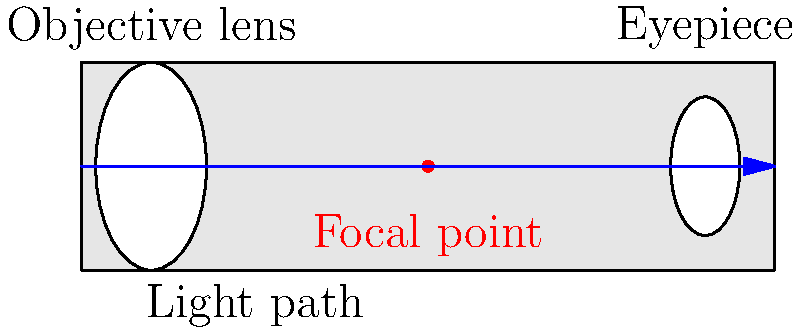In this cross-sectional diagram of a telescope, which component is responsible for gathering and focusing light from distant celestial objects, much like how a cinematographer captures expansive landscapes in classic Kannada films? To answer this question, let's break down the components of a telescope and their functions:

1. The telescope consists of two main optical components: the objective lens and the eyepiece.

2. The objective lens is the larger lens located at the front of the telescope (left side in the diagram). Its primary functions are:
   a) Gathering light from distant objects
   b) Focusing that light to form an image

3. The eyepiece is the smaller lens located at the back of the telescope (right side in the diagram). Its main function is to magnify the image formed by the objective lens.

4. The focal point, shown as a red dot in the diagram, is where the light rays converge after passing through the objective lens.

5. In cinematography, the camera lens serves a similar purpose to the objective lens in a telescope. It gathers light and focuses it to create an image on the film or sensor.

6. Just as a cinematographer uses different lenses to capture wide landscapes or close-up shots in Kannada films, astronomers use different objective lenses to observe various celestial objects.

Therefore, the component responsible for gathering and focusing light from distant celestial objects is the objective lens, which is analogous to the primary lens in a film camera.
Answer: Objective lens 